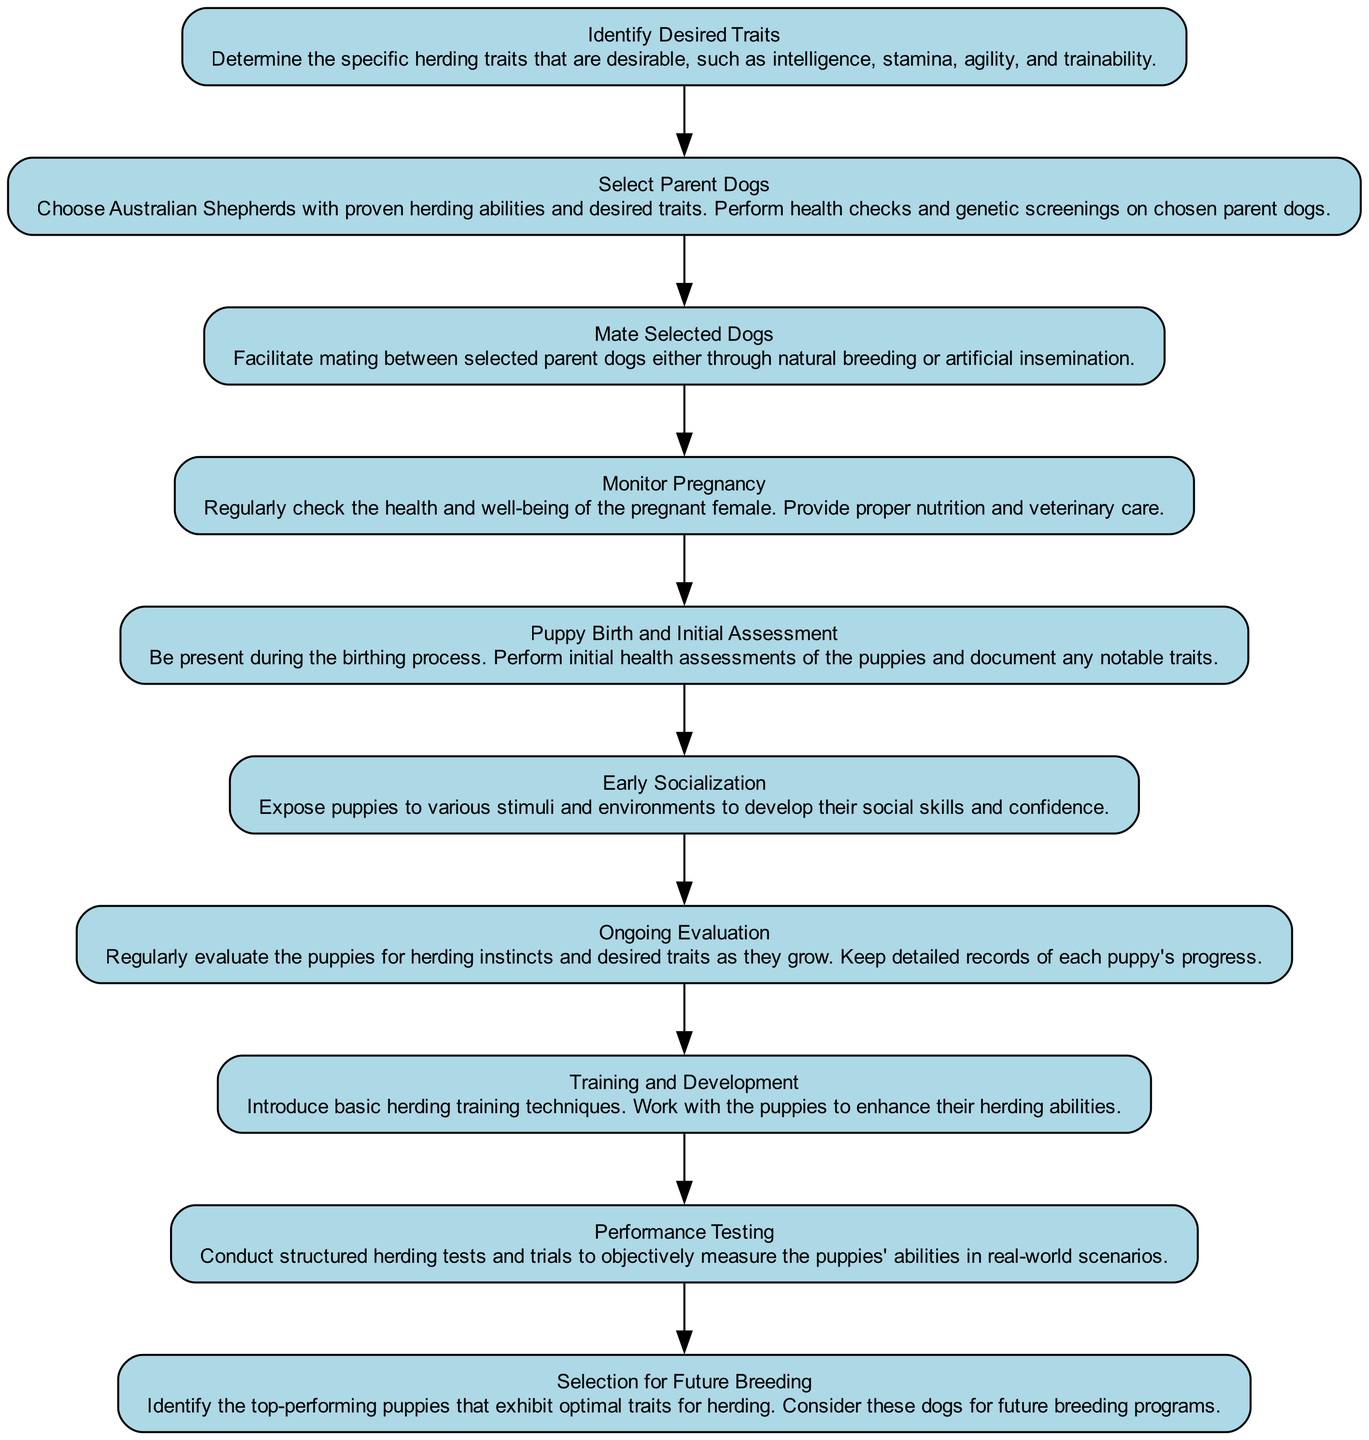What is the first step in the diagram? The diagram starts with the step titled "Identify Desired Traits," which focuses on determining the specific herding traits that are desirable.
Answer: Identify Desired Traits How many total steps are listed in the breeding program workflow? By counting each step listed in the diagram, there are a total of 10 steps that outline the workflow for breeding Australian Shepherds.
Answer: 10 What step follows "Puppy Birth and Initial Assessment"? The step that follows "Puppy Birth and Initial Assessment" in the workflow is "Early Socialization," which emphasizes exposing puppies to various stimuli for skill development.
Answer: Early Socialization What is the last step in the workflow? The last step in this breeding program workflow is "Selection for Future Breeding," where the top-performing puppies are identified for future breeding programs.
Answer: Selection for Future Breeding What is the focus of the "Ongoing Evaluation" step? The focus of the "Ongoing Evaluation" step is to regularly evaluate the puppies for herding instincts and desired traits as they grow, ensuring their progress is documented.
Answer: Evaluate puppies for herding instincts What is the connection between "Select Parent Dogs" and "Mate Selected Dogs"? The connection is that after selecting parent dogs based on health checks and desired traits in "Select Parent Dogs," those selected dogs are then mated in the following step "Mate Selected Dogs."
Answer: Mating selected dogs In which step is initial health assessment conducted? The initial health assessment of the puppies is conducted during the "Puppy Birth and Initial Assessment" step, where health checks are performed right after birth.
Answer: Puppy Birth and Initial Assessment What trait is emphasized during "Training and Development"? The emphasis during "Training and Development" is on enhancing the herding abilities of the puppies through basic herding training techniques.
Answer: Herding abilities What does the "Performance Testing" step measure? The "Performance Testing" step aims to conduct structured herding tests and trials to objectively measure the puppies' abilities in real-world scenarios.
Answer: Measure ability in real-world scenarios 